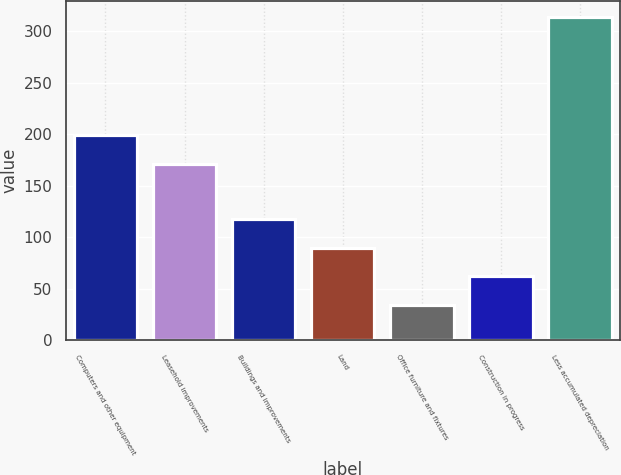<chart> <loc_0><loc_0><loc_500><loc_500><bar_chart><fcel>Computers and other equipment<fcel>Leasehold improvements<fcel>Buildings and improvements<fcel>Land<fcel>Office furniture and fixtures<fcel>Construction in progress<fcel>Less accumulated depreciation<nl><fcel>199<fcel>171<fcel>118<fcel>90<fcel>34<fcel>62<fcel>314<nl></chart> 